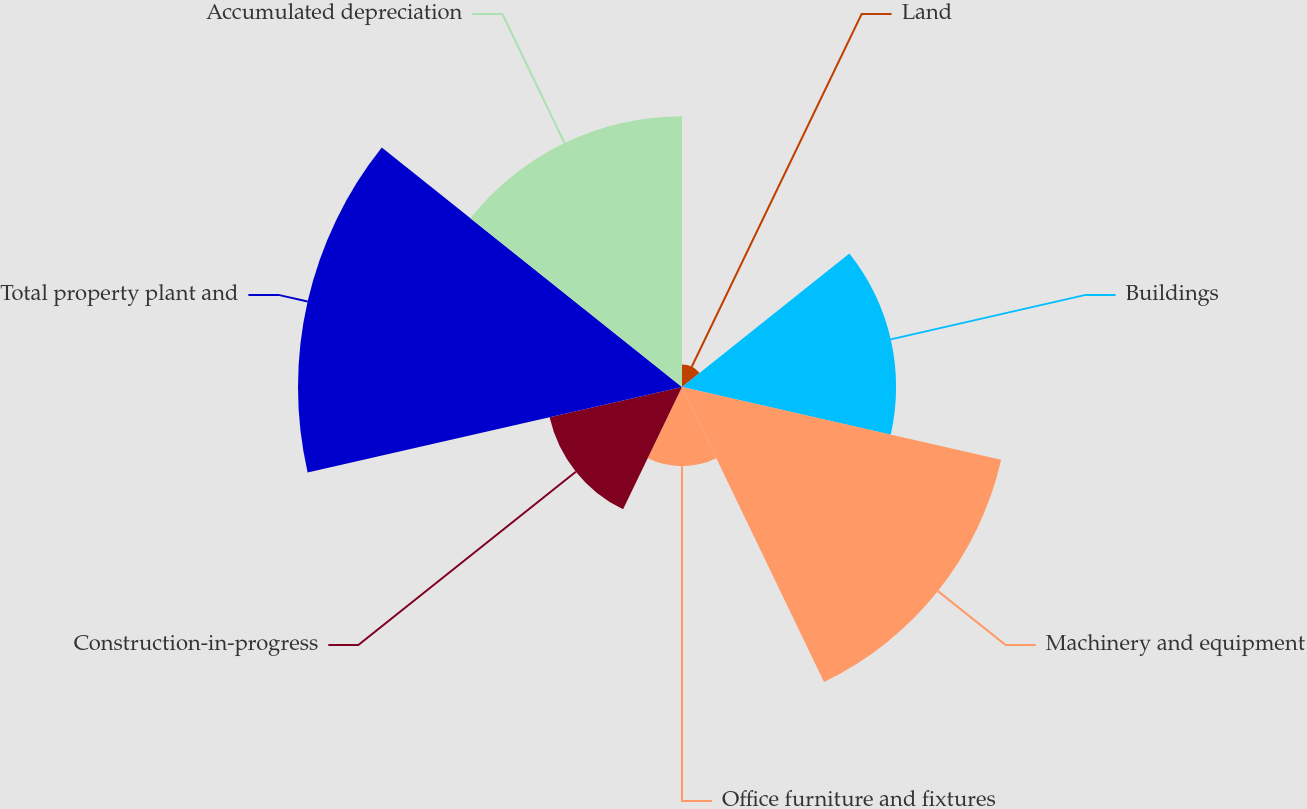Convert chart to OTSL. <chart><loc_0><loc_0><loc_500><loc_500><pie_chart><fcel>Land<fcel>Buildings<fcel>Machinery and equipment<fcel>Office furniture and fixtures<fcel>Construction-in-progress<fcel>Total property plant and<fcel>Accumulated depreciation<nl><fcel>1.57%<fcel>14.93%<fcel>22.83%<fcel>5.52%<fcel>9.47%<fcel>26.78%<fcel>18.88%<nl></chart> 